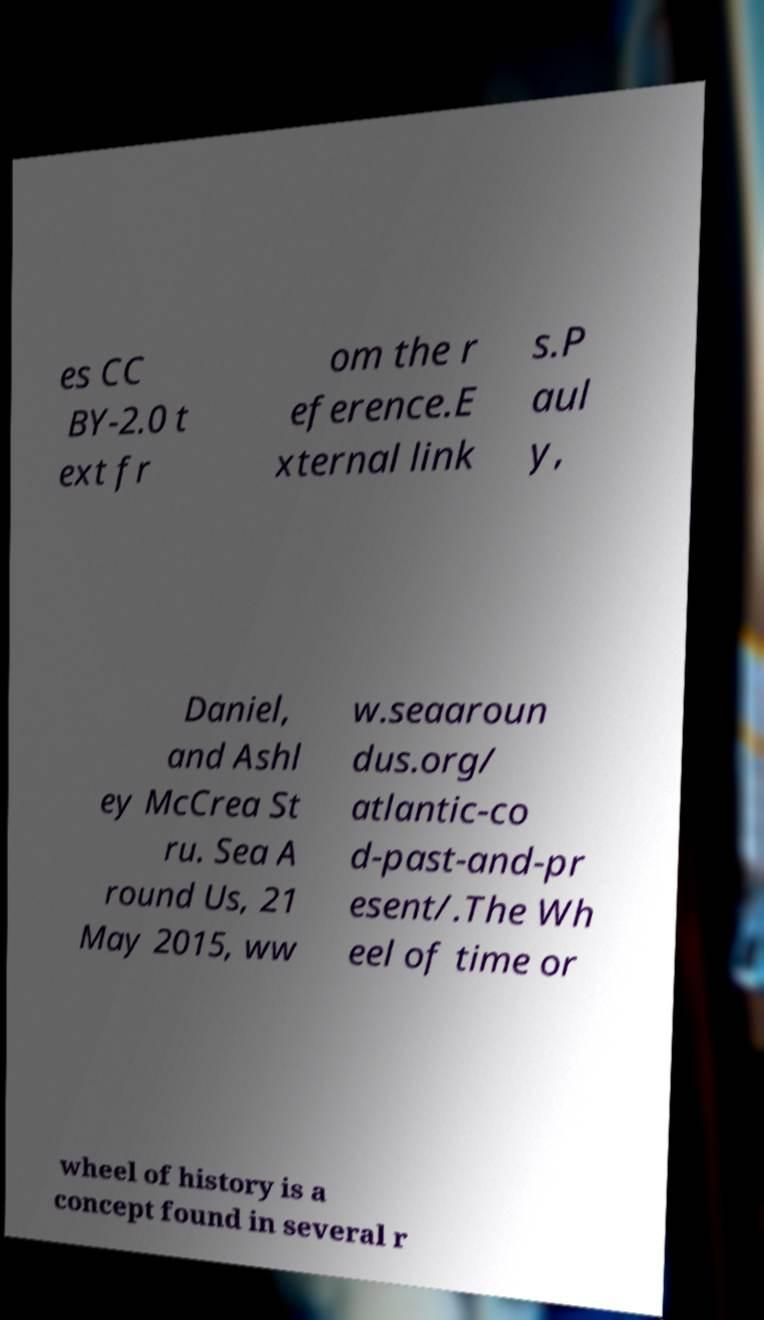I need the written content from this picture converted into text. Can you do that? es CC BY-2.0 t ext fr om the r eference.E xternal link s.P aul y, Daniel, and Ashl ey McCrea St ru. Sea A round Us, 21 May 2015, ww w.seaaroun dus.org/ atlantic-co d-past-and-pr esent/.The Wh eel of time or wheel of history is a concept found in several r 